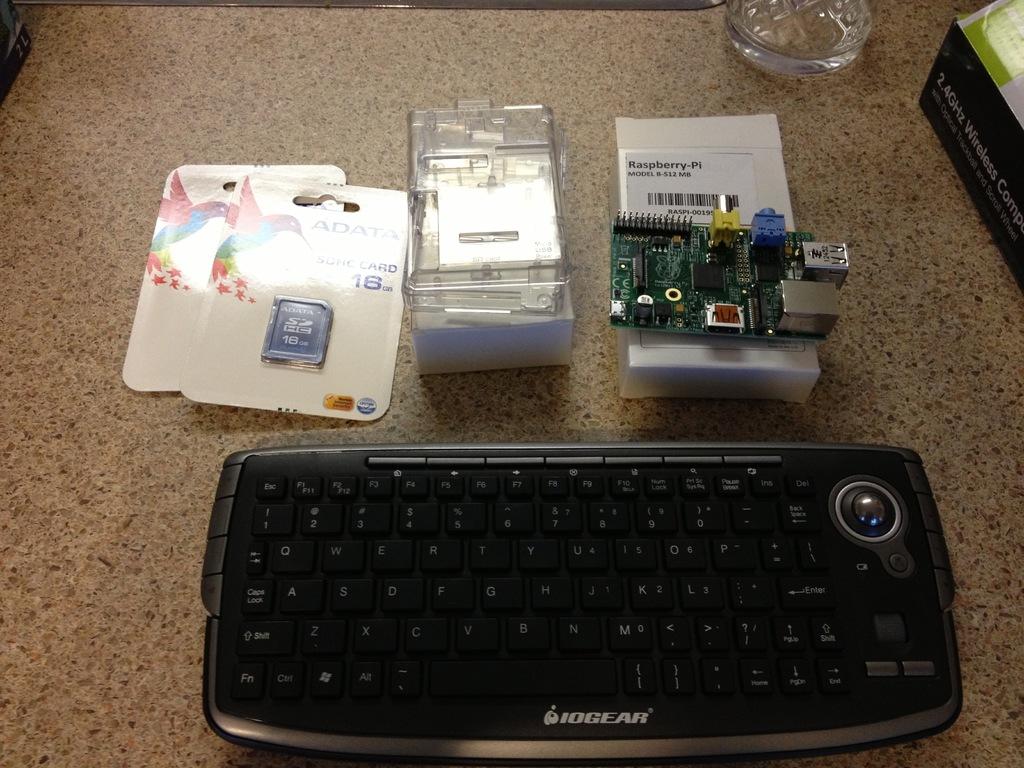Who made the keyboard?
Your response must be concise. Iogear. 